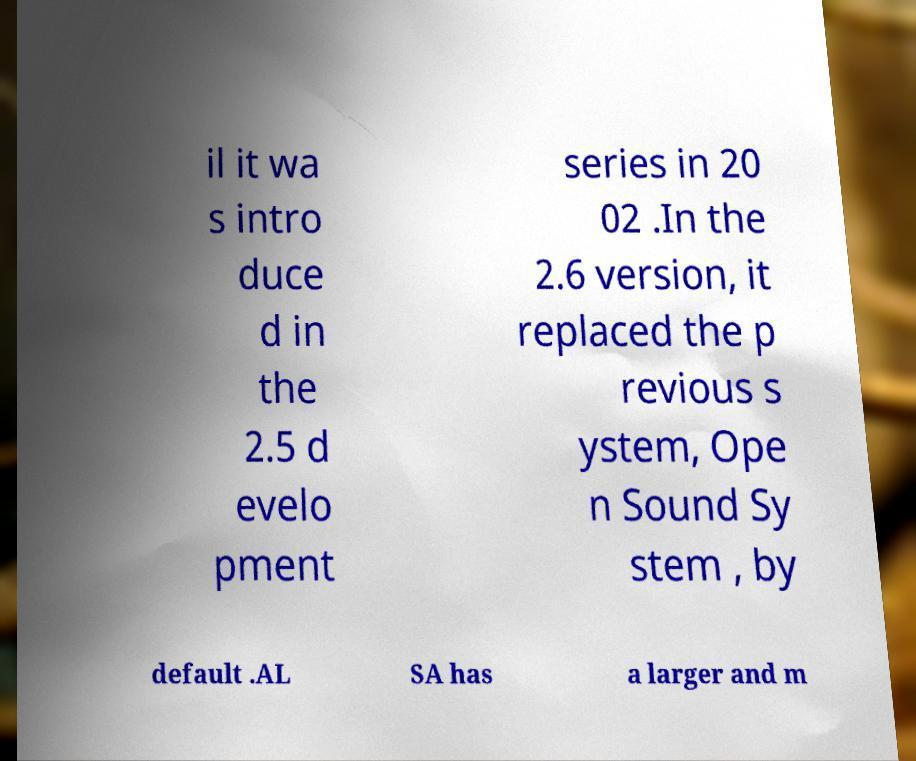What messages or text are displayed in this image? I need them in a readable, typed format. il it wa s intro duce d in the 2.5 d evelo pment series in 20 02 .In the 2.6 version, it replaced the p revious s ystem, Ope n Sound Sy stem , by default .AL SA has a larger and m 